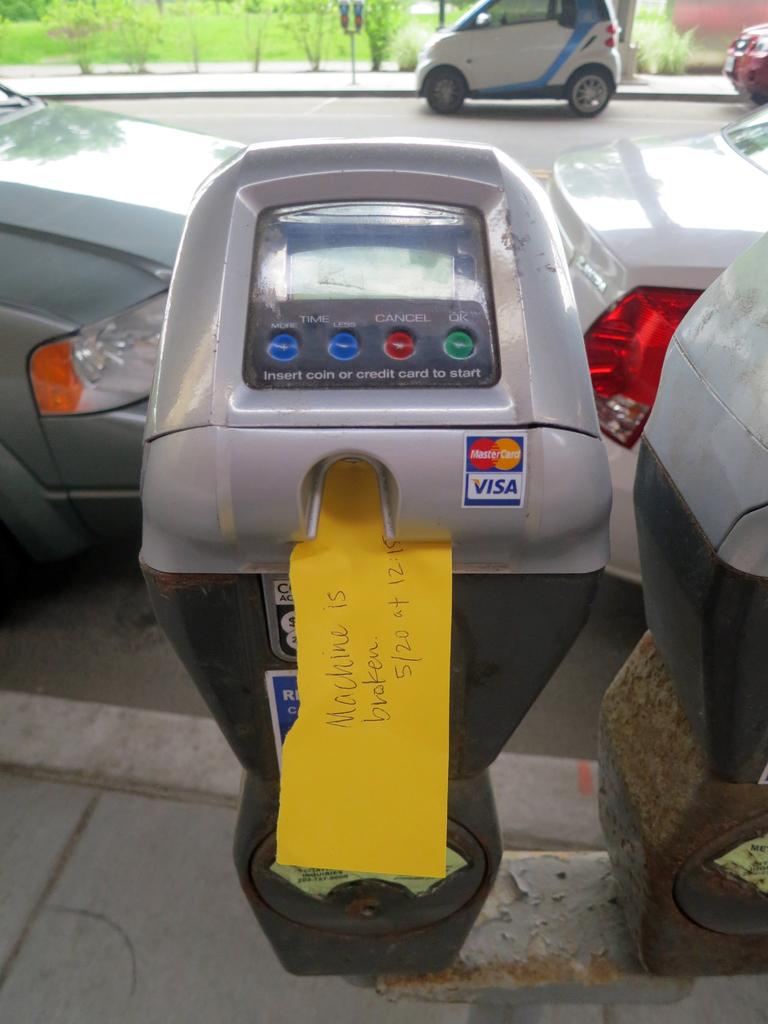<image>
Describe the image concisely. a parking meter has a yellow sign reading Machine is Broken on it 